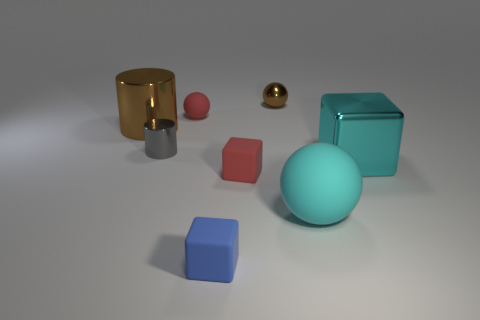Subtract all brown balls. How many balls are left? 2 Subtract all brown cylinders. How many cylinders are left? 1 Add 2 red blocks. How many objects exist? 10 Subtract 2 cylinders. How many cylinders are left? 0 Add 3 blue matte objects. How many blue matte objects exist? 4 Subtract 1 brown balls. How many objects are left? 7 Subtract all cylinders. How many objects are left? 6 Subtract all yellow cylinders. Subtract all gray blocks. How many cylinders are left? 2 Subtract all large objects. Subtract all small matte cubes. How many objects are left? 3 Add 1 small gray cylinders. How many small gray cylinders are left? 2 